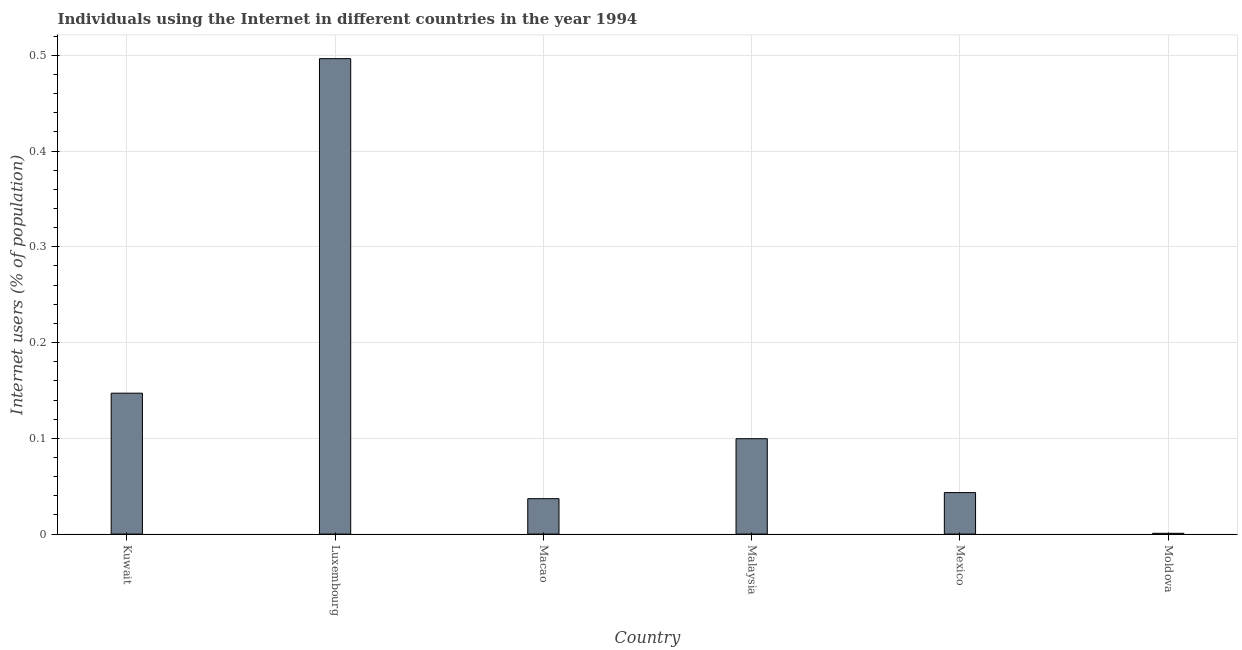What is the title of the graph?
Offer a terse response. Individuals using the Internet in different countries in the year 1994. What is the label or title of the Y-axis?
Offer a terse response. Internet users (% of population). What is the number of internet users in Macao?
Your answer should be compact. 0.04. Across all countries, what is the maximum number of internet users?
Make the answer very short. 0.5. Across all countries, what is the minimum number of internet users?
Offer a terse response. 0. In which country was the number of internet users maximum?
Your answer should be compact. Luxembourg. In which country was the number of internet users minimum?
Offer a terse response. Moldova. What is the sum of the number of internet users?
Your response must be concise. 0.82. What is the difference between the number of internet users in Kuwait and Macao?
Your response must be concise. 0.11. What is the average number of internet users per country?
Offer a very short reply. 0.14. What is the median number of internet users?
Give a very brief answer. 0.07. What is the ratio of the number of internet users in Kuwait to that in Moldova?
Your answer should be compact. 178.29. What is the difference between the highest and the second highest number of internet users?
Your response must be concise. 0.35. Is the sum of the number of internet users in Luxembourg and Moldova greater than the maximum number of internet users across all countries?
Make the answer very short. Yes. In how many countries, is the number of internet users greater than the average number of internet users taken over all countries?
Your response must be concise. 2. Are all the bars in the graph horizontal?
Offer a terse response. No. Are the values on the major ticks of Y-axis written in scientific E-notation?
Keep it short and to the point. No. What is the Internet users (% of population) in Kuwait?
Give a very brief answer. 0.15. What is the Internet users (% of population) in Luxembourg?
Ensure brevity in your answer.  0.5. What is the Internet users (% of population) of Macao?
Make the answer very short. 0.04. What is the Internet users (% of population) in Malaysia?
Ensure brevity in your answer.  0.1. What is the Internet users (% of population) in Mexico?
Offer a terse response. 0.04. What is the Internet users (% of population) in Moldova?
Keep it short and to the point. 0. What is the difference between the Internet users (% of population) in Kuwait and Luxembourg?
Your answer should be compact. -0.35. What is the difference between the Internet users (% of population) in Kuwait and Macao?
Your answer should be compact. 0.11. What is the difference between the Internet users (% of population) in Kuwait and Malaysia?
Ensure brevity in your answer.  0.05. What is the difference between the Internet users (% of population) in Kuwait and Mexico?
Make the answer very short. 0.1. What is the difference between the Internet users (% of population) in Kuwait and Moldova?
Ensure brevity in your answer.  0.15. What is the difference between the Internet users (% of population) in Luxembourg and Macao?
Keep it short and to the point. 0.46. What is the difference between the Internet users (% of population) in Luxembourg and Malaysia?
Your response must be concise. 0.4. What is the difference between the Internet users (% of population) in Luxembourg and Mexico?
Your response must be concise. 0.45. What is the difference between the Internet users (% of population) in Luxembourg and Moldova?
Give a very brief answer. 0.5. What is the difference between the Internet users (% of population) in Macao and Malaysia?
Provide a short and direct response. -0.06. What is the difference between the Internet users (% of population) in Macao and Mexico?
Provide a short and direct response. -0.01. What is the difference between the Internet users (% of population) in Macao and Moldova?
Offer a terse response. 0.04. What is the difference between the Internet users (% of population) in Malaysia and Mexico?
Your answer should be compact. 0.06. What is the difference between the Internet users (% of population) in Malaysia and Moldova?
Give a very brief answer. 0.1. What is the difference between the Internet users (% of population) in Mexico and Moldova?
Your answer should be very brief. 0.04. What is the ratio of the Internet users (% of population) in Kuwait to that in Luxembourg?
Ensure brevity in your answer.  0.3. What is the ratio of the Internet users (% of population) in Kuwait to that in Macao?
Ensure brevity in your answer.  3.98. What is the ratio of the Internet users (% of population) in Kuwait to that in Malaysia?
Make the answer very short. 1.48. What is the ratio of the Internet users (% of population) in Kuwait to that in Mexico?
Make the answer very short. 3.4. What is the ratio of the Internet users (% of population) in Kuwait to that in Moldova?
Offer a terse response. 178.29. What is the ratio of the Internet users (% of population) in Luxembourg to that in Macao?
Provide a succinct answer. 13.42. What is the ratio of the Internet users (% of population) in Luxembourg to that in Malaysia?
Provide a short and direct response. 4.98. What is the ratio of the Internet users (% of population) in Luxembourg to that in Mexico?
Your answer should be very brief. 11.46. What is the ratio of the Internet users (% of population) in Luxembourg to that in Moldova?
Ensure brevity in your answer.  601.52. What is the ratio of the Internet users (% of population) in Macao to that in Malaysia?
Your response must be concise. 0.37. What is the ratio of the Internet users (% of population) in Macao to that in Mexico?
Your answer should be compact. 0.85. What is the ratio of the Internet users (% of population) in Macao to that in Moldova?
Give a very brief answer. 44.82. What is the ratio of the Internet users (% of population) in Malaysia to that in Mexico?
Ensure brevity in your answer.  2.3. What is the ratio of the Internet users (% of population) in Malaysia to that in Moldova?
Make the answer very short. 120.68. What is the ratio of the Internet users (% of population) in Mexico to that in Moldova?
Provide a short and direct response. 52.51. 